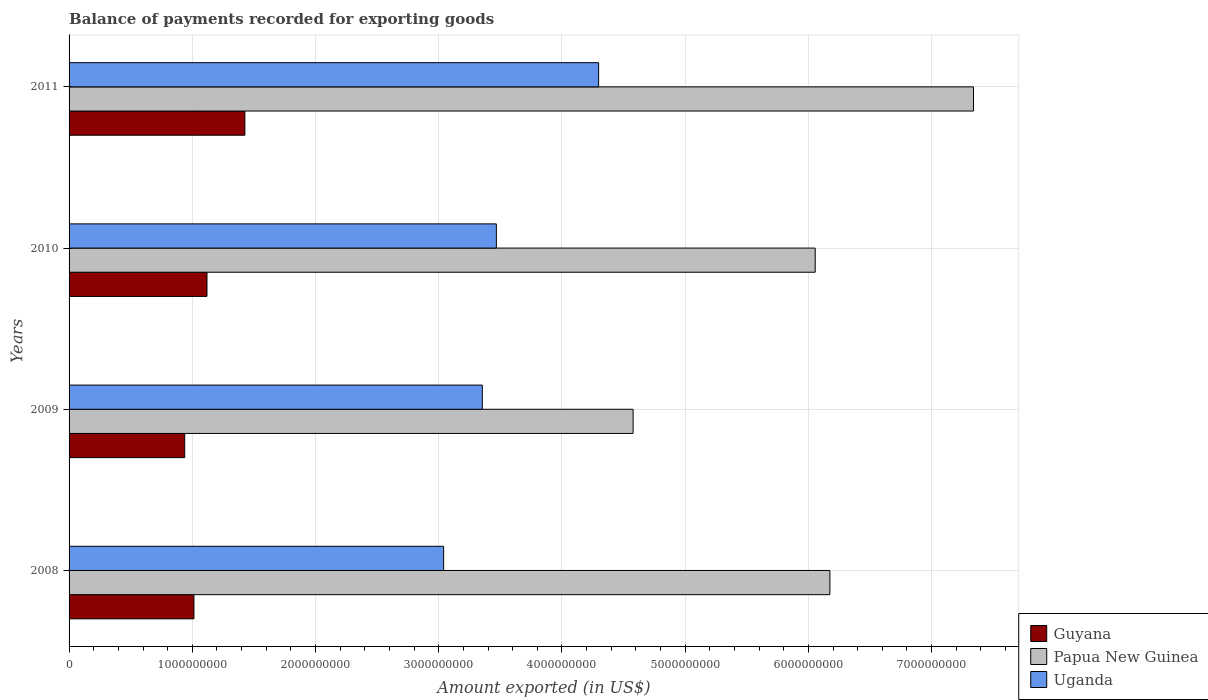How many different coloured bars are there?
Your answer should be compact. 3. Are the number of bars on each tick of the Y-axis equal?
Make the answer very short. Yes. What is the label of the 4th group of bars from the top?
Offer a very short reply. 2008. What is the amount exported in Papua New Guinea in 2010?
Keep it short and to the point. 6.06e+09. Across all years, what is the maximum amount exported in Papua New Guinea?
Your response must be concise. 7.34e+09. Across all years, what is the minimum amount exported in Papua New Guinea?
Provide a succinct answer. 4.58e+09. What is the total amount exported in Uganda in the graph?
Keep it short and to the point. 1.42e+1. What is the difference between the amount exported in Papua New Guinea in 2008 and that in 2010?
Your answer should be very brief. 1.19e+08. What is the difference between the amount exported in Uganda in 2010 and the amount exported in Papua New Guinea in 2011?
Ensure brevity in your answer.  -3.87e+09. What is the average amount exported in Papua New Guinea per year?
Provide a succinct answer. 6.04e+09. In the year 2008, what is the difference between the amount exported in Uganda and amount exported in Guyana?
Keep it short and to the point. 2.03e+09. In how many years, is the amount exported in Papua New Guinea greater than 1000000000 US$?
Give a very brief answer. 4. What is the ratio of the amount exported in Papua New Guinea in 2009 to that in 2010?
Offer a very short reply. 0.76. What is the difference between the highest and the second highest amount exported in Papua New Guinea?
Keep it short and to the point. 1.17e+09. What is the difference between the highest and the lowest amount exported in Guyana?
Provide a short and direct response. 4.88e+08. In how many years, is the amount exported in Papua New Guinea greater than the average amount exported in Papua New Guinea taken over all years?
Keep it short and to the point. 3. What does the 3rd bar from the top in 2008 represents?
Provide a succinct answer. Guyana. What does the 1st bar from the bottom in 2011 represents?
Provide a short and direct response. Guyana. Is it the case that in every year, the sum of the amount exported in Uganda and amount exported in Guyana is greater than the amount exported in Papua New Guinea?
Provide a succinct answer. No. How many bars are there?
Make the answer very short. 12. How many years are there in the graph?
Your response must be concise. 4. What is the difference between two consecutive major ticks on the X-axis?
Provide a short and direct response. 1.00e+09. Does the graph contain any zero values?
Give a very brief answer. No. How many legend labels are there?
Make the answer very short. 3. What is the title of the graph?
Offer a very short reply. Balance of payments recorded for exporting goods. Does "Guyana" appear as one of the legend labels in the graph?
Ensure brevity in your answer.  Yes. What is the label or title of the X-axis?
Provide a short and direct response. Amount exported (in US$). What is the Amount exported (in US$) in Guyana in 2008?
Provide a short and direct response. 1.01e+09. What is the Amount exported (in US$) in Papua New Guinea in 2008?
Provide a short and direct response. 6.17e+09. What is the Amount exported (in US$) in Uganda in 2008?
Keep it short and to the point. 3.04e+09. What is the Amount exported (in US$) in Guyana in 2009?
Your answer should be compact. 9.38e+08. What is the Amount exported (in US$) in Papua New Guinea in 2009?
Keep it short and to the point. 4.58e+09. What is the Amount exported (in US$) of Uganda in 2009?
Your response must be concise. 3.35e+09. What is the Amount exported (in US$) of Guyana in 2010?
Give a very brief answer. 1.12e+09. What is the Amount exported (in US$) of Papua New Guinea in 2010?
Keep it short and to the point. 6.06e+09. What is the Amount exported (in US$) in Uganda in 2010?
Offer a terse response. 3.47e+09. What is the Amount exported (in US$) in Guyana in 2011?
Ensure brevity in your answer.  1.43e+09. What is the Amount exported (in US$) of Papua New Guinea in 2011?
Your answer should be very brief. 7.34e+09. What is the Amount exported (in US$) in Uganda in 2011?
Provide a short and direct response. 4.30e+09. Across all years, what is the maximum Amount exported (in US$) in Guyana?
Offer a terse response. 1.43e+09. Across all years, what is the maximum Amount exported (in US$) in Papua New Guinea?
Provide a short and direct response. 7.34e+09. Across all years, what is the maximum Amount exported (in US$) in Uganda?
Keep it short and to the point. 4.30e+09. Across all years, what is the minimum Amount exported (in US$) in Guyana?
Offer a terse response. 9.38e+08. Across all years, what is the minimum Amount exported (in US$) of Papua New Guinea?
Give a very brief answer. 4.58e+09. Across all years, what is the minimum Amount exported (in US$) of Uganda?
Ensure brevity in your answer.  3.04e+09. What is the total Amount exported (in US$) of Guyana in the graph?
Your answer should be very brief. 4.50e+09. What is the total Amount exported (in US$) in Papua New Guinea in the graph?
Make the answer very short. 2.41e+1. What is the total Amount exported (in US$) of Uganda in the graph?
Provide a short and direct response. 1.42e+1. What is the difference between the Amount exported (in US$) of Guyana in 2008 and that in 2009?
Keep it short and to the point. 7.49e+07. What is the difference between the Amount exported (in US$) in Papua New Guinea in 2008 and that in 2009?
Make the answer very short. 1.60e+09. What is the difference between the Amount exported (in US$) of Uganda in 2008 and that in 2009?
Keep it short and to the point. -3.14e+08. What is the difference between the Amount exported (in US$) of Guyana in 2008 and that in 2010?
Your answer should be compact. -1.06e+08. What is the difference between the Amount exported (in US$) in Papua New Guinea in 2008 and that in 2010?
Your response must be concise. 1.19e+08. What is the difference between the Amount exported (in US$) of Uganda in 2008 and that in 2010?
Offer a very short reply. -4.28e+08. What is the difference between the Amount exported (in US$) in Guyana in 2008 and that in 2011?
Provide a short and direct response. -4.13e+08. What is the difference between the Amount exported (in US$) in Papua New Guinea in 2008 and that in 2011?
Your response must be concise. -1.17e+09. What is the difference between the Amount exported (in US$) of Uganda in 2008 and that in 2011?
Your response must be concise. -1.26e+09. What is the difference between the Amount exported (in US$) of Guyana in 2009 and that in 2010?
Keep it short and to the point. -1.81e+08. What is the difference between the Amount exported (in US$) of Papua New Guinea in 2009 and that in 2010?
Keep it short and to the point. -1.48e+09. What is the difference between the Amount exported (in US$) in Uganda in 2009 and that in 2010?
Offer a terse response. -1.14e+08. What is the difference between the Amount exported (in US$) in Guyana in 2009 and that in 2011?
Your response must be concise. -4.88e+08. What is the difference between the Amount exported (in US$) of Papua New Guinea in 2009 and that in 2011?
Keep it short and to the point. -2.76e+09. What is the difference between the Amount exported (in US$) in Uganda in 2009 and that in 2011?
Make the answer very short. -9.44e+08. What is the difference between the Amount exported (in US$) in Guyana in 2010 and that in 2011?
Provide a succinct answer. -3.07e+08. What is the difference between the Amount exported (in US$) in Papua New Guinea in 2010 and that in 2011?
Provide a short and direct response. -1.28e+09. What is the difference between the Amount exported (in US$) in Uganda in 2010 and that in 2011?
Offer a very short reply. -8.30e+08. What is the difference between the Amount exported (in US$) of Guyana in 2008 and the Amount exported (in US$) of Papua New Guinea in 2009?
Provide a succinct answer. -3.56e+09. What is the difference between the Amount exported (in US$) of Guyana in 2008 and the Amount exported (in US$) of Uganda in 2009?
Offer a terse response. -2.34e+09. What is the difference between the Amount exported (in US$) in Papua New Guinea in 2008 and the Amount exported (in US$) in Uganda in 2009?
Your answer should be compact. 2.82e+09. What is the difference between the Amount exported (in US$) in Guyana in 2008 and the Amount exported (in US$) in Papua New Guinea in 2010?
Your answer should be compact. -5.04e+09. What is the difference between the Amount exported (in US$) of Guyana in 2008 and the Amount exported (in US$) of Uganda in 2010?
Your answer should be very brief. -2.45e+09. What is the difference between the Amount exported (in US$) of Papua New Guinea in 2008 and the Amount exported (in US$) of Uganda in 2010?
Make the answer very short. 2.71e+09. What is the difference between the Amount exported (in US$) of Guyana in 2008 and the Amount exported (in US$) of Papua New Guinea in 2011?
Provide a succinct answer. -6.33e+09. What is the difference between the Amount exported (in US$) in Guyana in 2008 and the Amount exported (in US$) in Uganda in 2011?
Provide a succinct answer. -3.28e+09. What is the difference between the Amount exported (in US$) in Papua New Guinea in 2008 and the Amount exported (in US$) in Uganda in 2011?
Your answer should be compact. 1.88e+09. What is the difference between the Amount exported (in US$) of Guyana in 2009 and the Amount exported (in US$) of Papua New Guinea in 2010?
Ensure brevity in your answer.  -5.12e+09. What is the difference between the Amount exported (in US$) in Guyana in 2009 and the Amount exported (in US$) in Uganda in 2010?
Your answer should be very brief. -2.53e+09. What is the difference between the Amount exported (in US$) in Papua New Guinea in 2009 and the Amount exported (in US$) in Uganda in 2010?
Ensure brevity in your answer.  1.11e+09. What is the difference between the Amount exported (in US$) of Guyana in 2009 and the Amount exported (in US$) of Papua New Guinea in 2011?
Your response must be concise. -6.40e+09. What is the difference between the Amount exported (in US$) in Guyana in 2009 and the Amount exported (in US$) in Uganda in 2011?
Make the answer very short. -3.36e+09. What is the difference between the Amount exported (in US$) in Papua New Guinea in 2009 and the Amount exported (in US$) in Uganda in 2011?
Provide a short and direct response. 2.80e+08. What is the difference between the Amount exported (in US$) in Guyana in 2010 and the Amount exported (in US$) in Papua New Guinea in 2011?
Keep it short and to the point. -6.22e+09. What is the difference between the Amount exported (in US$) in Guyana in 2010 and the Amount exported (in US$) in Uganda in 2011?
Your answer should be compact. -3.18e+09. What is the difference between the Amount exported (in US$) in Papua New Guinea in 2010 and the Amount exported (in US$) in Uganda in 2011?
Your response must be concise. 1.76e+09. What is the average Amount exported (in US$) of Guyana per year?
Offer a very short reply. 1.12e+09. What is the average Amount exported (in US$) of Papua New Guinea per year?
Provide a short and direct response. 6.04e+09. What is the average Amount exported (in US$) of Uganda per year?
Keep it short and to the point. 3.54e+09. In the year 2008, what is the difference between the Amount exported (in US$) in Guyana and Amount exported (in US$) in Papua New Guinea?
Make the answer very short. -5.16e+09. In the year 2008, what is the difference between the Amount exported (in US$) in Guyana and Amount exported (in US$) in Uganda?
Ensure brevity in your answer.  -2.03e+09. In the year 2008, what is the difference between the Amount exported (in US$) of Papua New Guinea and Amount exported (in US$) of Uganda?
Keep it short and to the point. 3.13e+09. In the year 2009, what is the difference between the Amount exported (in US$) of Guyana and Amount exported (in US$) of Papua New Guinea?
Your answer should be compact. -3.64e+09. In the year 2009, what is the difference between the Amount exported (in US$) in Guyana and Amount exported (in US$) in Uganda?
Your answer should be very brief. -2.42e+09. In the year 2009, what is the difference between the Amount exported (in US$) of Papua New Guinea and Amount exported (in US$) of Uganda?
Your answer should be compact. 1.22e+09. In the year 2010, what is the difference between the Amount exported (in US$) of Guyana and Amount exported (in US$) of Papua New Guinea?
Make the answer very short. -4.94e+09. In the year 2010, what is the difference between the Amount exported (in US$) in Guyana and Amount exported (in US$) in Uganda?
Make the answer very short. -2.35e+09. In the year 2010, what is the difference between the Amount exported (in US$) in Papua New Guinea and Amount exported (in US$) in Uganda?
Keep it short and to the point. 2.59e+09. In the year 2011, what is the difference between the Amount exported (in US$) of Guyana and Amount exported (in US$) of Papua New Guinea?
Offer a terse response. -5.91e+09. In the year 2011, what is the difference between the Amount exported (in US$) of Guyana and Amount exported (in US$) of Uganda?
Your answer should be very brief. -2.87e+09. In the year 2011, what is the difference between the Amount exported (in US$) of Papua New Guinea and Amount exported (in US$) of Uganda?
Your response must be concise. 3.04e+09. What is the ratio of the Amount exported (in US$) of Guyana in 2008 to that in 2009?
Ensure brevity in your answer.  1.08. What is the ratio of the Amount exported (in US$) of Papua New Guinea in 2008 to that in 2009?
Your answer should be compact. 1.35. What is the ratio of the Amount exported (in US$) of Uganda in 2008 to that in 2009?
Give a very brief answer. 0.91. What is the ratio of the Amount exported (in US$) in Guyana in 2008 to that in 2010?
Provide a succinct answer. 0.91. What is the ratio of the Amount exported (in US$) in Papua New Guinea in 2008 to that in 2010?
Offer a terse response. 1.02. What is the ratio of the Amount exported (in US$) of Uganda in 2008 to that in 2010?
Give a very brief answer. 0.88. What is the ratio of the Amount exported (in US$) in Guyana in 2008 to that in 2011?
Your response must be concise. 0.71. What is the ratio of the Amount exported (in US$) in Papua New Guinea in 2008 to that in 2011?
Offer a very short reply. 0.84. What is the ratio of the Amount exported (in US$) in Uganda in 2008 to that in 2011?
Make the answer very short. 0.71. What is the ratio of the Amount exported (in US$) of Guyana in 2009 to that in 2010?
Make the answer very short. 0.84. What is the ratio of the Amount exported (in US$) of Papua New Guinea in 2009 to that in 2010?
Keep it short and to the point. 0.76. What is the ratio of the Amount exported (in US$) in Uganda in 2009 to that in 2010?
Keep it short and to the point. 0.97. What is the ratio of the Amount exported (in US$) of Guyana in 2009 to that in 2011?
Offer a very short reply. 0.66. What is the ratio of the Amount exported (in US$) of Papua New Guinea in 2009 to that in 2011?
Provide a succinct answer. 0.62. What is the ratio of the Amount exported (in US$) of Uganda in 2009 to that in 2011?
Offer a very short reply. 0.78. What is the ratio of the Amount exported (in US$) of Guyana in 2010 to that in 2011?
Provide a short and direct response. 0.78. What is the ratio of the Amount exported (in US$) in Papua New Guinea in 2010 to that in 2011?
Give a very brief answer. 0.82. What is the ratio of the Amount exported (in US$) of Uganda in 2010 to that in 2011?
Provide a short and direct response. 0.81. What is the difference between the highest and the second highest Amount exported (in US$) in Guyana?
Your answer should be very brief. 3.07e+08. What is the difference between the highest and the second highest Amount exported (in US$) of Papua New Guinea?
Keep it short and to the point. 1.17e+09. What is the difference between the highest and the second highest Amount exported (in US$) in Uganda?
Make the answer very short. 8.30e+08. What is the difference between the highest and the lowest Amount exported (in US$) in Guyana?
Offer a very short reply. 4.88e+08. What is the difference between the highest and the lowest Amount exported (in US$) in Papua New Guinea?
Make the answer very short. 2.76e+09. What is the difference between the highest and the lowest Amount exported (in US$) in Uganda?
Keep it short and to the point. 1.26e+09. 